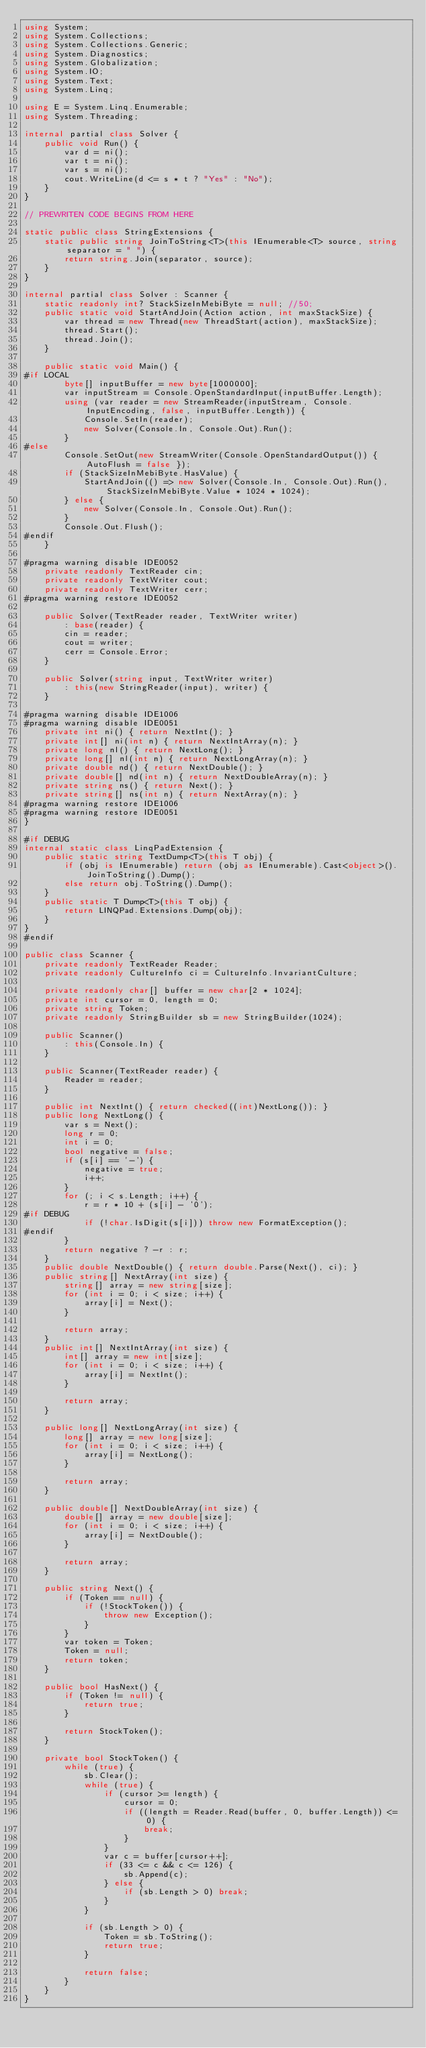Convert code to text. <code><loc_0><loc_0><loc_500><loc_500><_C#_>using System;
using System.Collections;
using System.Collections.Generic;
using System.Diagnostics;
using System.Globalization;
using System.IO;
using System.Text;
using System.Linq;

using E = System.Linq.Enumerable;
using System.Threading;

internal partial class Solver {
    public void Run() {
        var d = ni();
        var t = ni();
        var s = ni();
        cout.WriteLine(d <= s * t ? "Yes" : "No");
    }
}

// PREWRITEN CODE BEGINS FROM HERE

static public class StringExtensions {
    static public string JoinToString<T>(this IEnumerable<T> source, string separator = " ") {
        return string.Join(separator, source);
    }
}

internal partial class Solver : Scanner {
    static readonly int? StackSizeInMebiByte = null; //50;
    public static void StartAndJoin(Action action, int maxStackSize) {
        var thread = new Thread(new ThreadStart(action), maxStackSize);
        thread.Start();
        thread.Join();
    }

    public static void Main() {
#if LOCAL
        byte[] inputBuffer = new byte[1000000];
        var inputStream = Console.OpenStandardInput(inputBuffer.Length);
        using (var reader = new StreamReader(inputStream, Console.InputEncoding, false, inputBuffer.Length)) {
            Console.SetIn(reader);
            new Solver(Console.In, Console.Out).Run();
        }
#else
        Console.SetOut(new StreamWriter(Console.OpenStandardOutput()) { AutoFlush = false });
        if (StackSizeInMebiByte.HasValue) {
            StartAndJoin(() => new Solver(Console.In, Console.Out).Run(), StackSizeInMebiByte.Value * 1024 * 1024);
        } else {
            new Solver(Console.In, Console.Out).Run();
        }
        Console.Out.Flush();
#endif
    }

#pragma warning disable IDE0052
    private readonly TextReader cin;
    private readonly TextWriter cout;
    private readonly TextWriter cerr;
#pragma warning restore IDE0052

    public Solver(TextReader reader, TextWriter writer)
        : base(reader) {
        cin = reader;
        cout = writer;
        cerr = Console.Error;
    }

    public Solver(string input, TextWriter writer)
        : this(new StringReader(input), writer) {
    }

#pragma warning disable IDE1006
#pragma warning disable IDE0051
    private int ni() { return NextInt(); }
    private int[] ni(int n) { return NextIntArray(n); }
    private long nl() { return NextLong(); }
    private long[] nl(int n) { return NextLongArray(n); }
    private double nd() { return NextDouble(); }
    private double[] nd(int n) { return NextDoubleArray(n); }
    private string ns() { return Next(); }
    private string[] ns(int n) { return NextArray(n); }
#pragma warning restore IDE1006
#pragma warning restore IDE0051
}

#if DEBUG
internal static class LinqPadExtension {
    public static string TextDump<T>(this T obj) {
        if (obj is IEnumerable) return (obj as IEnumerable).Cast<object>().JoinToString().Dump();
        else return obj.ToString().Dump();
    }
    public static T Dump<T>(this T obj) {
        return LINQPad.Extensions.Dump(obj);
    }
}
#endif

public class Scanner {
    private readonly TextReader Reader;
    private readonly CultureInfo ci = CultureInfo.InvariantCulture;

    private readonly char[] buffer = new char[2 * 1024];
    private int cursor = 0, length = 0;
    private string Token;
    private readonly StringBuilder sb = new StringBuilder(1024);

    public Scanner()
        : this(Console.In) {
    }

    public Scanner(TextReader reader) {
        Reader = reader;
    }

    public int NextInt() { return checked((int)NextLong()); }
    public long NextLong() {
        var s = Next();
        long r = 0;
        int i = 0;
        bool negative = false;
        if (s[i] == '-') {
            negative = true;
            i++;
        }
        for (; i < s.Length; i++) {
            r = r * 10 + (s[i] - '0');
#if DEBUG
            if (!char.IsDigit(s[i])) throw new FormatException();
#endif
        }
        return negative ? -r : r;
    }
    public double NextDouble() { return double.Parse(Next(), ci); }
    public string[] NextArray(int size) {
        string[] array = new string[size];
        for (int i = 0; i < size; i++) {
            array[i] = Next();
        }

        return array;
    }
    public int[] NextIntArray(int size) {
        int[] array = new int[size];
        for (int i = 0; i < size; i++) {
            array[i] = NextInt();
        }

        return array;
    }

    public long[] NextLongArray(int size) {
        long[] array = new long[size];
        for (int i = 0; i < size; i++) {
            array[i] = NextLong();
        }

        return array;
    }

    public double[] NextDoubleArray(int size) {
        double[] array = new double[size];
        for (int i = 0; i < size; i++) {
            array[i] = NextDouble();
        }

        return array;
    }

    public string Next() {
        if (Token == null) {
            if (!StockToken()) {
                throw new Exception();
            }
        }
        var token = Token;
        Token = null;
        return token;
    }

    public bool HasNext() {
        if (Token != null) {
            return true;
        }

        return StockToken();
    }

    private bool StockToken() {
        while (true) {
            sb.Clear();
            while (true) {
                if (cursor >= length) {
                    cursor = 0;
                    if ((length = Reader.Read(buffer, 0, buffer.Length)) <= 0) {
                        break;
                    }
                }
                var c = buffer[cursor++];
                if (33 <= c && c <= 126) {
                    sb.Append(c);
                } else {
                    if (sb.Length > 0) break;
                }
            }

            if (sb.Length > 0) {
                Token = sb.ToString();
                return true;
            }

            return false;
        }
    }
}</code> 